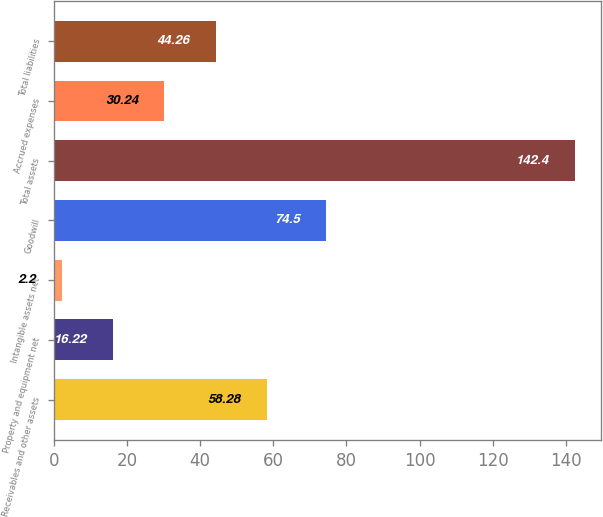Convert chart to OTSL. <chart><loc_0><loc_0><loc_500><loc_500><bar_chart><fcel>Receivables and other assets<fcel>Property and equipment net<fcel>Intangible assets net<fcel>Goodwill<fcel>Total assets<fcel>Accrued expenses<fcel>Total liabilities<nl><fcel>58.28<fcel>16.22<fcel>2.2<fcel>74.5<fcel>142.4<fcel>30.24<fcel>44.26<nl></chart> 